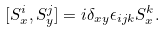<formula> <loc_0><loc_0><loc_500><loc_500>[ S _ { x } ^ { i } , S _ { y } ^ { j } ] = i \delta _ { x y } \epsilon _ { i j k } S _ { x } ^ { k } .</formula> 